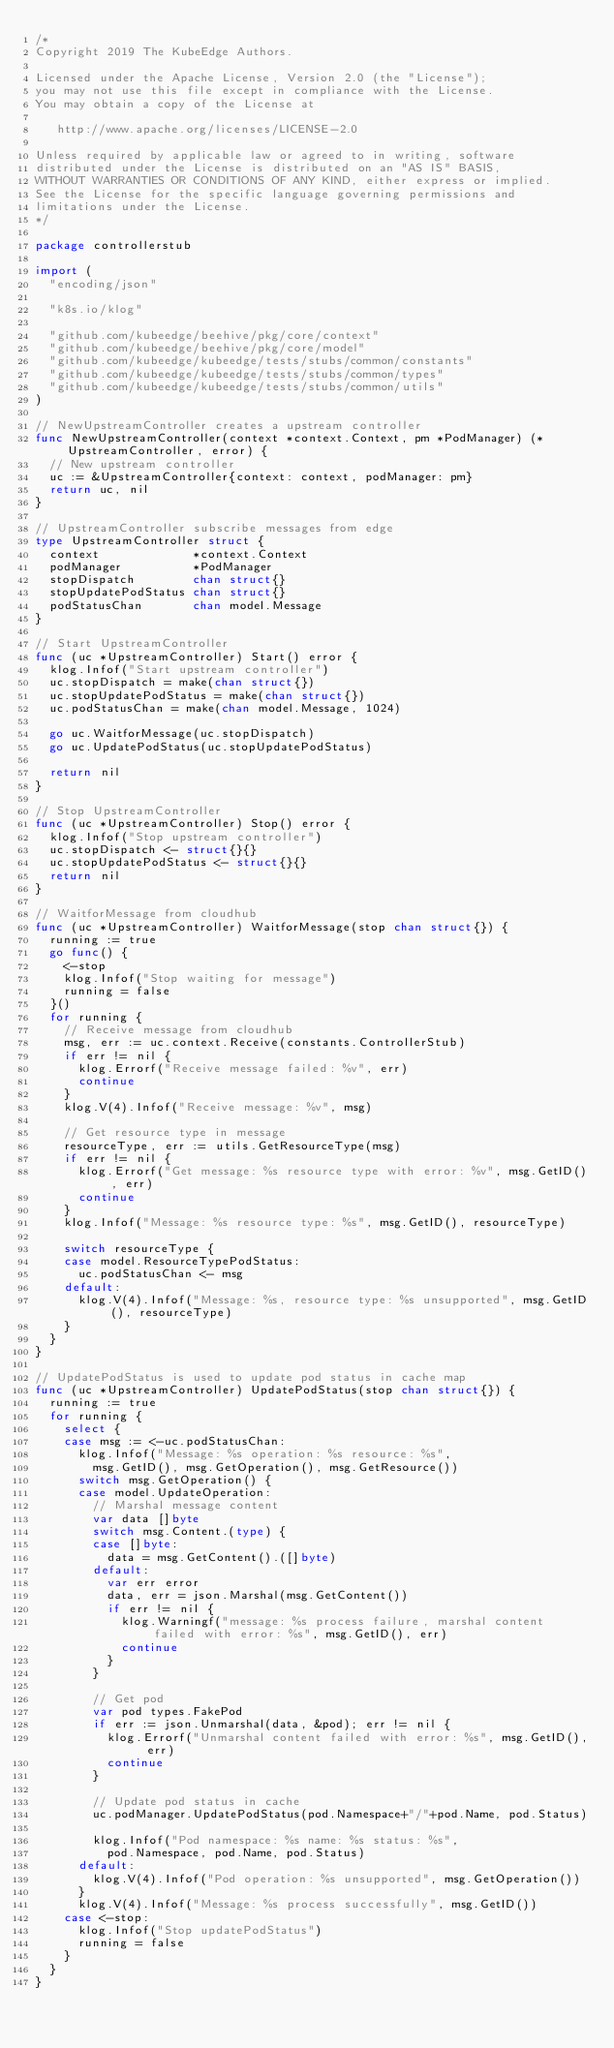<code> <loc_0><loc_0><loc_500><loc_500><_Go_>/*
Copyright 2019 The KubeEdge Authors.

Licensed under the Apache License, Version 2.0 (the "License");
you may not use this file except in compliance with the License.
You may obtain a copy of the License at

   http://www.apache.org/licenses/LICENSE-2.0

Unless required by applicable law or agreed to in writing, software
distributed under the License is distributed on an "AS IS" BASIS,
WITHOUT WARRANTIES OR CONDITIONS OF ANY KIND, either express or implied.
See the License for the specific language governing permissions and
limitations under the License.
*/

package controllerstub

import (
	"encoding/json"

	"k8s.io/klog"

	"github.com/kubeedge/beehive/pkg/core/context"
	"github.com/kubeedge/beehive/pkg/core/model"
	"github.com/kubeedge/kubeedge/tests/stubs/common/constants"
	"github.com/kubeedge/kubeedge/tests/stubs/common/types"
	"github.com/kubeedge/kubeedge/tests/stubs/common/utils"
)

// NewUpstreamController creates a upstream controller
func NewUpstreamController(context *context.Context, pm *PodManager) (*UpstreamController, error) {
	// New upstream controller
	uc := &UpstreamController{context: context, podManager: pm}
	return uc, nil
}

// UpstreamController subscribe messages from edge
type UpstreamController struct {
	context             *context.Context
	podManager          *PodManager
	stopDispatch        chan struct{}
	stopUpdatePodStatus chan struct{}
	podStatusChan       chan model.Message
}

// Start UpstreamController
func (uc *UpstreamController) Start() error {
	klog.Infof("Start upstream controller")
	uc.stopDispatch = make(chan struct{})
	uc.stopUpdatePodStatus = make(chan struct{})
	uc.podStatusChan = make(chan model.Message, 1024)

	go uc.WaitforMessage(uc.stopDispatch)
	go uc.UpdatePodStatus(uc.stopUpdatePodStatus)

	return nil
}

// Stop UpstreamController
func (uc *UpstreamController) Stop() error {
	klog.Infof("Stop upstream controller")
	uc.stopDispatch <- struct{}{}
	uc.stopUpdatePodStatus <- struct{}{}
	return nil
}

// WaitforMessage from cloudhub
func (uc *UpstreamController) WaitforMessage(stop chan struct{}) {
	running := true
	go func() {
		<-stop
		klog.Infof("Stop waiting for message")
		running = false
	}()
	for running {
		// Receive message from cloudhub
		msg, err := uc.context.Receive(constants.ControllerStub)
		if err != nil {
			klog.Errorf("Receive message failed: %v", err)
			continue
		}
		klog.V(4).Infof("Receive message: %v", msg)

		// Get resource type in message
		resourceType, err := utils.GetResourceType(msg)
		if err != nil {
			klog.Errorf("Get message: %s resource type with error: %v", msg.GetID(), err)
			continue
		}
		klog.Infof("Message: %s resource type: %s", msg.GetID(), resourceType)

		switch resourceType {
		case model.ResourceTypePodStatus:
			uc.podStatusChan <- msg
		default:
			klog.V(4).Infof("Message: %s, resource type: %s unsupported", msg.GetID(), resourceType)
		}
	}
}

// UpdatePodStatus is used to update pod status in cache map
func (uc *UpstreamController) UpdatePodStatus(stop chan struct{}) {
	running := true
	for running {
		select {
		case msg := <-uc.podStatusChan:
			klog.Infof("Message: %s operation: %s resource: %s",
				msg.GetID(), msg.GetOperation(), msg.GetResource())
			switch msg.GetOperation() {
			case model.UpdateOperation:
				// Marshal message content
				var data []byte
				switch msg.Content.(type) {
				case []byte:
					data = msg.GetContent().([]byte)
				default:
					var err error
					data, err = json.Marshal(msg.GetContent())
					if err != nil {
						klog.Warningf("message: %s process failure, marshal content failed with error: %s", msg.GetID(), err)
						continue
					}
				}

				// Get pod
				var pod types.FakePod
				if err := json.Unmarshal(data, &pod); err != nil {
					klog.Errorf("Unmarshal content failed with error: %s", msg.GetID(), err)
					continue
				}

				// Update pod status in cache
				uc.podManager.UpdatePodStatus(pod.Namespace+"/"+pod.Name, pod.Status)

				klog.Infof("Pod namespace: %s name: %s status: %s",
					pod.Namespace, pod.Name, pod.Status)
			default:
				klog.V(4).Infof("Pod operation: %s unsupported", msg.GetOperation())
			}
			klog.V(4).Infof("Message: %s process successfully", msg.GetID())
		case <-stop:
			klog.Infof("Stop updatePodStatus")
			running = false
		}
	}
}
</code> 